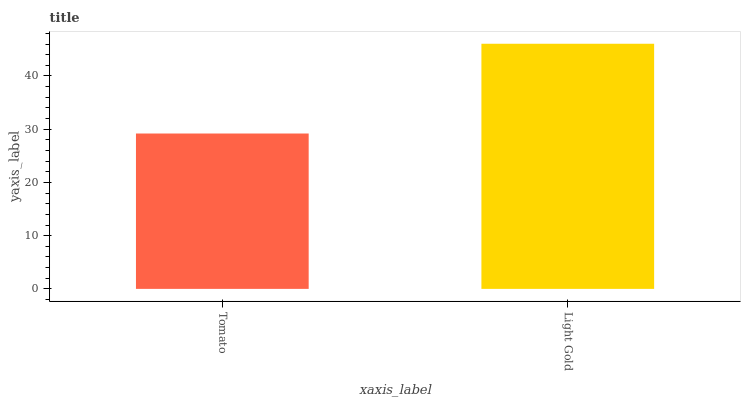Is Light Gold the minimum?
Answer yes or no. No. Is Light Gold greater than Tomato?
Answer yes or no. Yes. Is Tomato less than Light Gold?
Answer yes or no. Yes. Is Tomato greater than Light Gold?
Answer yes or no. No. Is Light Gold less than Tomato?
Answer yes or no. No. Is Light Gold the high median?
Answer yes or no. Yes. Is Tomato the low median?
Answer yes or no. Yes. Is Tomato the high median?
Answer yes or no. No. Is Light Gold the low median?
Answer yes or no. No. 